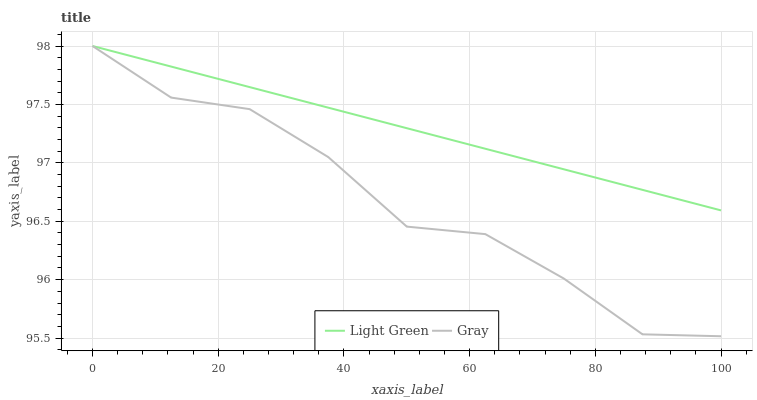Does Gray have the minimum area under the curve?
Answer yes or no. Yes. Does Light Green have the maximum area under the curve?
Answer yes or no. Yes. Does Light Green have the minimum area under the curve?
Answer yes or no. No. Is Light Green the smoothest?
Answer yes or no. Yes. Is Gray the roughest?
Answer yes or no. Yes. Is Light Green the roughest?
Answer yes or no. No. Does Gray have the lowest value?
Answer yes or no. Yes. Does Light Green have the lowest value?
Answer yes or no. No. Does Light Green have the highest value?
Answer yes or no. Yes. Does Gray intersect Light Green?
Answer yes or no. Yes. Is Gray less than Light Green?
Answer yes or no. No. Is Gray greater than Light Green?
Answer yes or no. No. 